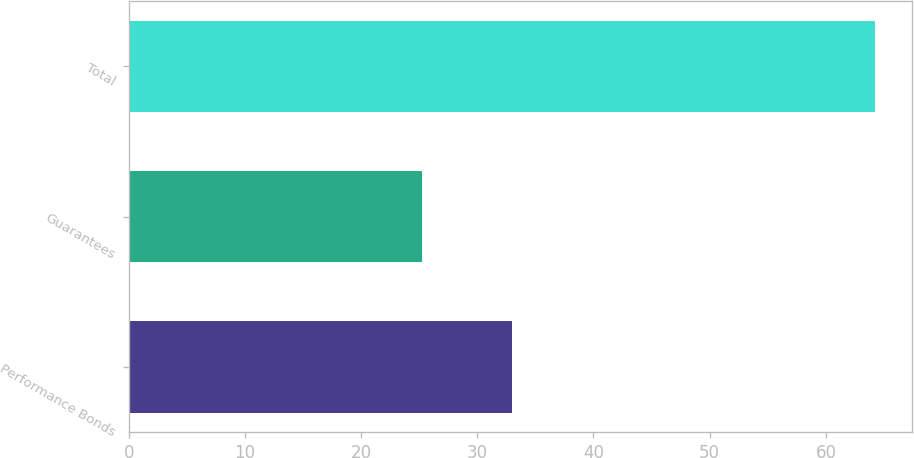Convert chart. <chart><loc_0><loc_0><loc_500><loc_500><bar_chart><fcel>Performance Bonds<fcel>Guarantees<fcel>Total<nl><fcel>33<fcel>25.2<fcel>64.2<nl></chart> 